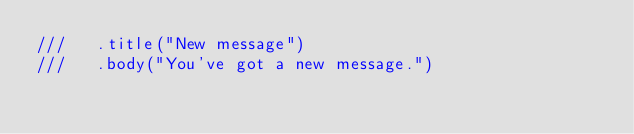Convert code to text. <code><loc_0><loc_0><loc_500><loc_500><_Rust_>///   .title("New message")
///   .body("You've got a new message.")</code> 